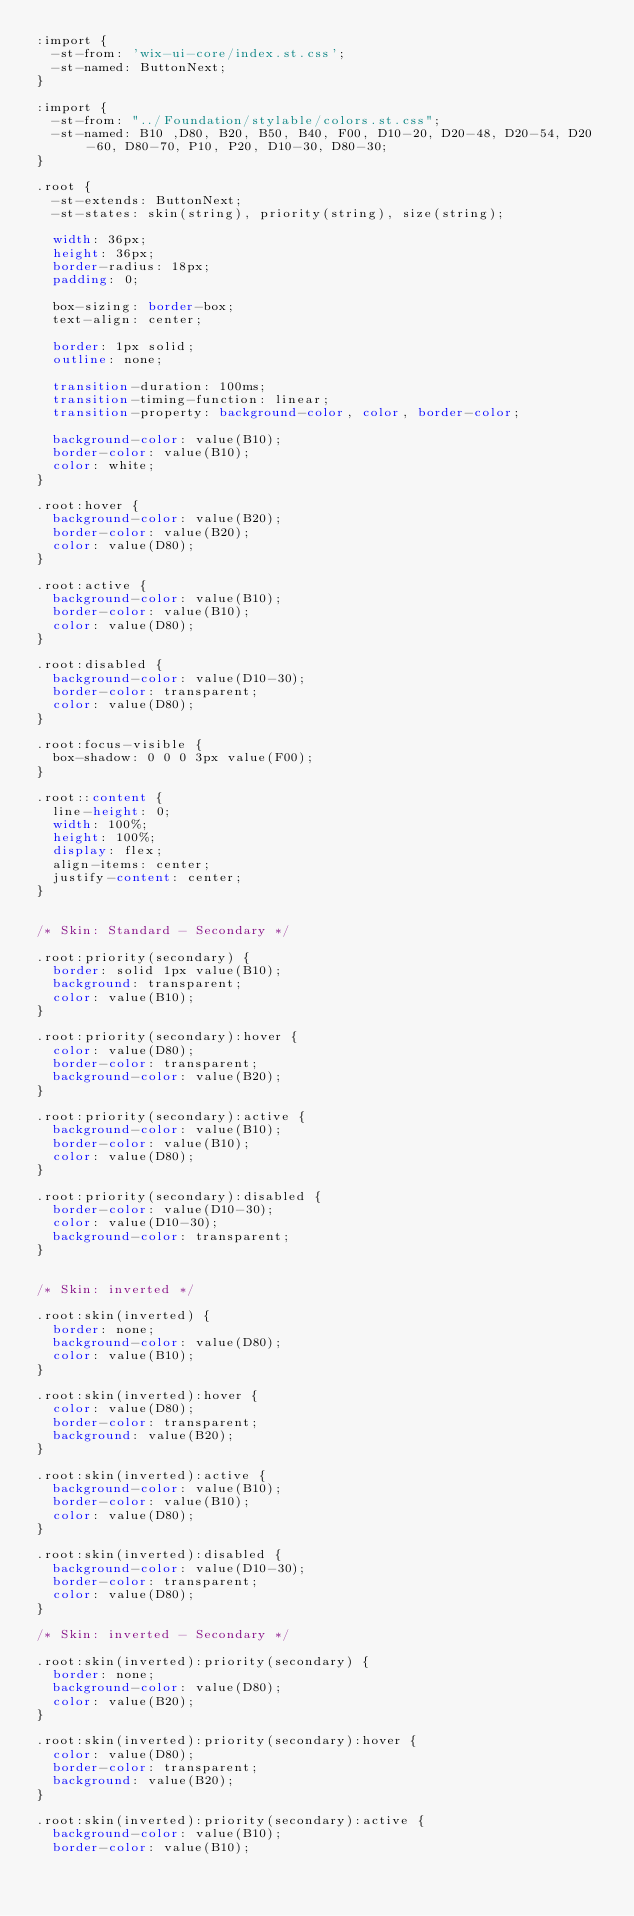Convert code to text. <code><loc_0><loc_0><loc_500><loc_500><_CSS_>:import {
  -st-from: 'wix-ui-core/index.st.css';
  -st-named: ButtonNext;
}

:import {
  -st-from: "../Foundation/stylable/colors.st.css";
  -st-named: B10 ,D80, B20, B50, B40, F00, D10-20, D20-48, D20-54, D20-60, D80-70, P10, P20, D10-30, D80-30;
}

.root {
  -st-extends: ButtonNext;
  -st-states: skin(string), priority(string), size(string);

  width: 36px;
  height: 36px;
  border-radius: 18px;
  padding: 0;

  box-sizing: border-box;
  text-align: center;

  border: 1px solid;
  outline: none;

  transition-duration: 100ms;
  transition-timing-function: linear;
  transition-property: background-color, color, border-color;

  background-color: value(B10);
  border-color: value(B10);
  color: white;
}

.root:hover {
  background-color: value(B20);
  border-color: value(B20);
  color: value(D80);
}

.root:active {
  background-color: value(B10);
  border-color: value(B10);
  color: value(D80);
}

.root:disabled {
  background-color: value(D10-30);
  border-color: transparent;
  color: value(D80);
}

.root:focus-visible {
  box-shadow: 0 0 0 3px value(F00);
}

.root::content {
  line-height: 0;
  width: 100%;
  height: 100%;
  display: flex;
  align-items: center;
  justify-content: center;
}


/* Skin: Standard - Secondary */

.root:priority(secondary) {
  border: solid 1px value(B10);
  background: transparent;
  color: value(B10);
}

.root:priority(secondary):hover {
  color: value(D80);
  border-color: transparent;
  background-color: value(B20);
}

.root:priority(secondary):active {
  background-color: value(B10);
  border-color: value(B10);
  color: value(D80);
}

.root:priority(secondary):disabled {
  border-color: value(D10-30);
  color: value(D10-30);
  background-color: transparent;
}


/* Skin: inverted */

.root:skin(inverted) {
  border: none;
  background-color: value(D80);
  color: value(B10);
}

.root:skin(inverted):hover {
  color: value(D80);
  border-color: transparent;
  background: value(B20);
}

.root:skin(inverted):active {
  background-color: value(B10);
  border-color: value(B10);
  color: value(D80);
}

.root:skin(inverted):disabled {
  background-color: value(D10-30);
  border-color: transparent;
  color: value(D80);
}

/* Skin: inverted - Secondary */

.root:skin(inverted):priority(secondary) {
  border: none;
  background-color: value(D80);
  color: value(B20);
}

.root:skin(inverted):priority(secondary):hover {
  color: value(D80);
  border-color: transparent;
  background: value(B20);
}

.root:skin(inverted):priority(secondary):active {
  background-color: value(B10);
  border-color: value(B10);</code> 